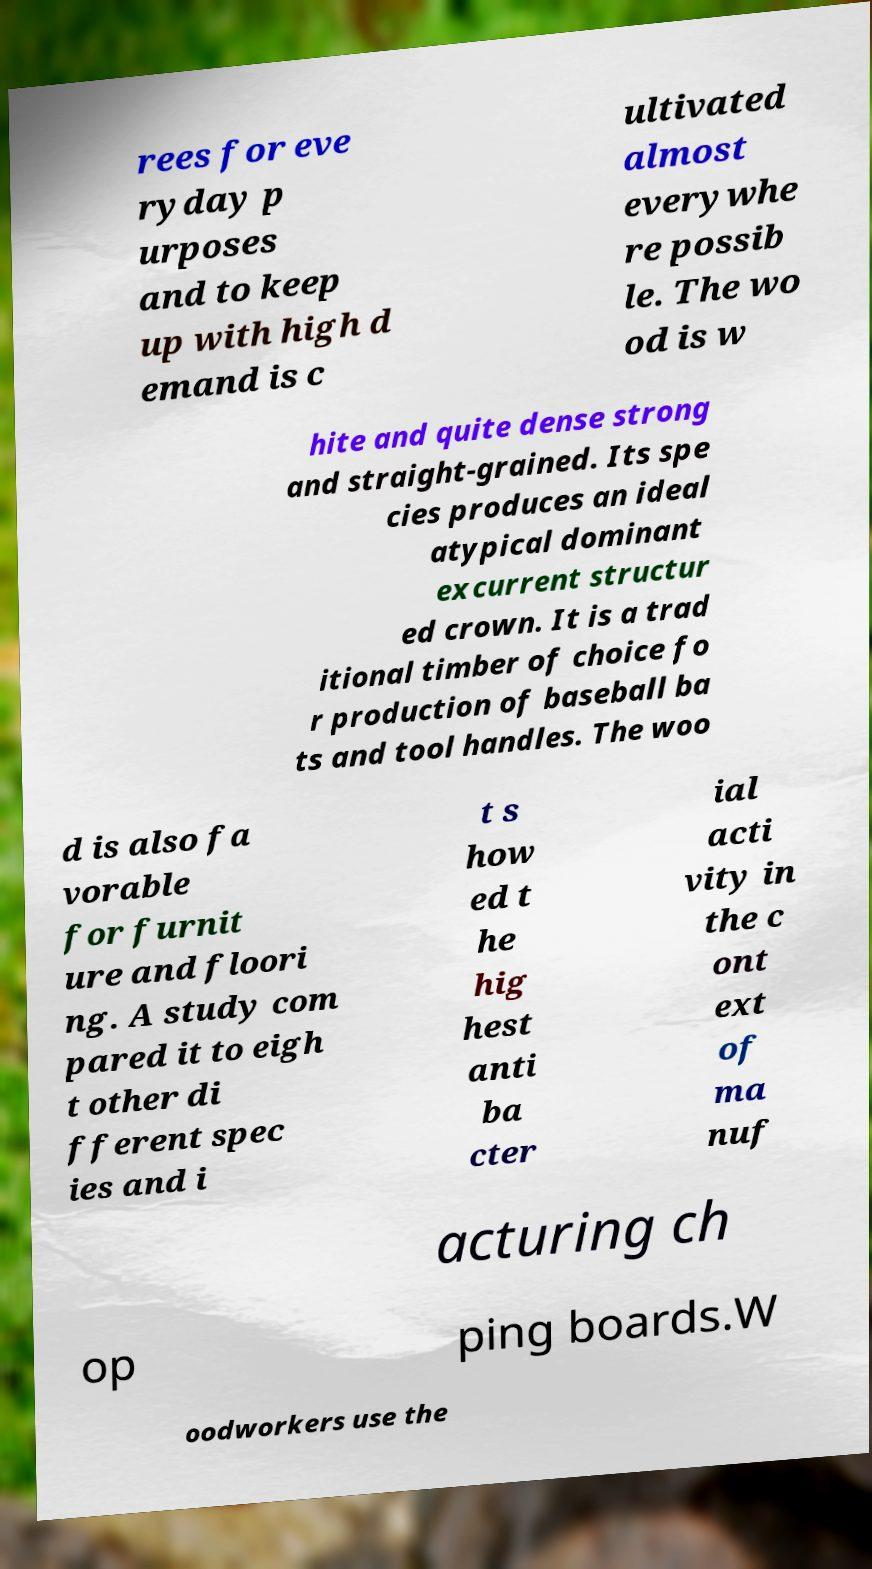Please identify and transcribe the text found in this image. rees for eve ryday p urposes and to keep up with high d emand is c ultivated almost everywhe re possib le. The wo od is w hite and quite dense strong and straight-grained. Its spe cies produces an ideal atypical dominant excurrent structur ed crown. It is a trad itional timber of choice fo r production of baseball ba ts and tool handles. The woo d is also fa vorable for furnit ure and floori ng. A study com pared it to eigh t other di fferent spec ies and i t s how ed t he hig hest anti ba cter ial acti vity in the c ont ext of ma nuf acturing ch op ping boards.W oodworkers use the 